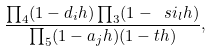<formula> <loc_0><loc_0><loc_500><loc_500>\frac { \prod _ { 4 } ( 1 - d _ { i } h ) \prod _ { 3 } ( 1 - \ s i _ { l } h ) } { \prod _ { 5 } ( 1 - a _ { j } h ) ( 1 - t h ) } ,</formula> 